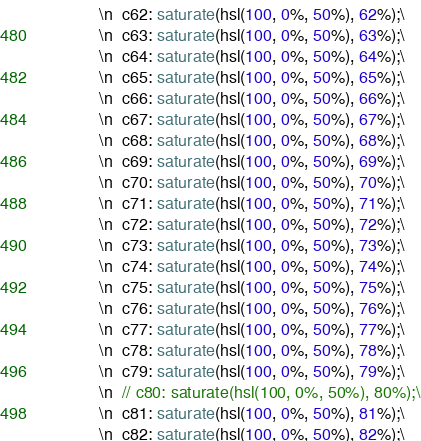Convert code to text. <code><loc_0><loc_0><loc_500><loc_500><_Rust_>            \n  c62: saturate(hsl(100, 0%, 50%), 62%);\
            \n  c63: saturate(hsl(100, 0%, 50%), 63%);\
            \n  c64: saturate(hsl(100, 0%, 50%), 64%);\
            \n  c65: saturate(hsl(100, 0%, 50%), 65%);\
            \n  c66: saturate(hsl(100, 0%, 50%), 66%);\
            \n  c67: saturate(hsl(100, 0%, 50%), 67%);\
            \n  c68: saturate(hsl(100, 0%, 50%), 68%);\
            \n  c69: saturate(hsl(100, 0%, 50%), 69%);\
            \n  c70: saturate(hsl(100, 0%, 50%), 70%);\
            \n  c71: saturate(hsl(100, 0%, 50%), 71%);\
            \n  c72: saturate(hsl(100, 0%, 50%), 72%);\
            \n  c73: saturate(hsl(100, 0%, 50%), 73%);\
            \n  c74: saturate(hsl(100, 0%, 50%), 74%);\
            \n  c75: saturate(hsl(100, 0%, 50%), 75%);\
            \n  c76: saturate(hsl(100, 0%, 50%), 76%);\
            \n  c77: saturate(hsl(100, 0%, 50%), 77%);\
            \n  c78: saturate(hsl(100, 0%, 50%), 78%);\
            \n  c79: saturate(hsl(100, 0%, 50%), 79%);\
            \n  // c80: saturate(hsl(100, 0%, 50%), 80%);\
            \n  c81: saturate(hsl(100, 0%, 50%), 81%);\
            \n  c82: saturate(hsl(100, 0%, 50%), 82%);\</code> 